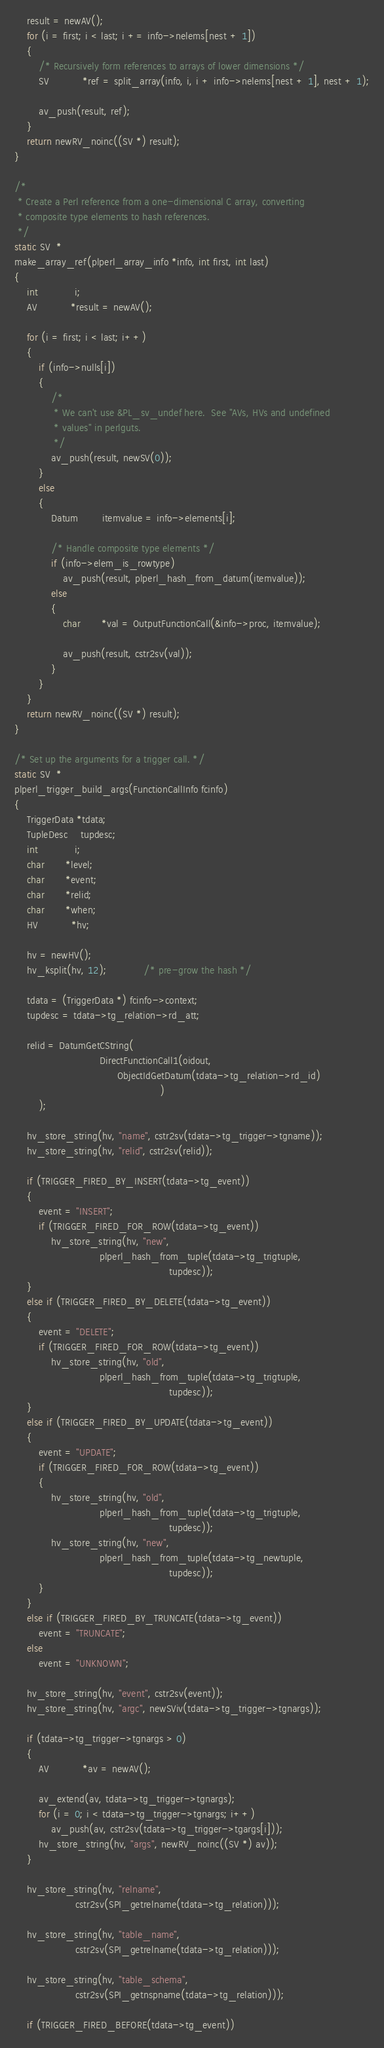<code> <loc_0><loc_0><loc_500><loc_500><_C_>	result = newAV();
	for (i = first; i < last; i += info->nelems[nest + 1])
	{
		/* Recursively form references to arrays of lower dimensions */
		SV		   *ref = split_array(info, i, i + info->nelems[nest + 1], nest + 1);

		av_push(result, ref);
	}
	return newRV_noinc((SV *) result);
}

/*
 * Create a Perl reference from a one-dimensional C array, converting
 * composite type elements to hash references.
 */
static SV  *
make_array_ref(plperl_array_info *info, int first, int last)
{
	int			i;
	AV		   *result = newAV();

	for (i = first; i < last; i++)
	{
		if (info->nulls[i])
		{
			/*
			 * We can't use &PL_sv_undef here.  See "AVs, HVs and undefined
			 * values" in perlguts.
			 */
			av_push(result, newSV(0));
		}
		else
		{
			Datum		itemvalue = info->elements[i];

			/* Handle composite type elements */
			if (info->elem_is_rowtype)
				av_push(result, plperl_hash_from_datum(itemvalue));
			else
			{
				char	   *val = OutputFunctionCall(&info->proc, itemvalue);

				av_push(result, cstr2sv(val));
			}
		}
	}
	return newRV_noinc((SV *) result);
}

/* Set up the arguments for a trigger call. */
static SV  *
plperl_trigger_build_args(FunctionCallInfo fcinfo)
{
	TriggerData *tdata;
	TupleDesc	tupdesc;
	int			i;
	char	   *level;
	char	   *event;
	char	   *relid;
	char	   *when;
	HV		   *hv;

	hv = newHV();
	hv_ksplit(hv, 12);			/* pre-grow the hash */

	tdata = (TriggerData *) fcinfo->context;
	tupdesc = tdata->tg_relation->rd_att;

	relid = DatumGetCString(
							DirectFunctionCall1(oidout,
								  ObjectIdGetDatum(tdata->tg_relation->rd_id)
												)
		);

	hv_store_string(hv, "name", cstr2sv(tdata->tg_trigger->tgname));
	hv_store_string(hv, "relid", cstr2sv(relid));

	if (TRIGGER_FIRED_BY_INSERT(tdata->tg_event))
	{
		event = "INSERT";
		if (TRIGGER_FIRED_FOR_ROW(tdata->tg_event))
			hv_store_string(hv, "new",
							plperl_hash_from_tuple(tdata->tg_trigtuple,
												   tupdesc));
	}
	else if (TRIGGER_FIRED_BY_DELETE(tdata->tg_event))
	{
		event = "DELETE";
		if (TRIGGER_FIRED_FOR_ROW(tdata->tg_event))
			hv_store_string(hv, "old",
							plperl_hash_from_tuple(tdata->tg_trigtuple,
												   tupdesc));
	}
	else if (TRIGGER_FIRED_BY_UPDATE(tdata->tg_event))
	{
		event = "UPDATE";
		if (TRIGGER_FIRED_FOR_ROW(tdata->tg_event))
		{
			hv_store_string(hv, "old",
							plperl_hash_from_tuple(tdata->tg_trigtuple,
												   tupdesc));
			hv_store_string(hv, "new",
							plperl_hash_from_tuple(tdata->tg_newtuple,
												   tupdesc));
		}
	}
	else if (TRIGGER_FIRED_BY_TRUNCATE(tdata->tg_event))
		event = "TRUNCATE";
	else
		event = "UNKNOWN";

	hv_store_string(hv, "event", cstr2sv(event));
	hv_store_string(hv, "argc", newSViv(tdata->tg_trigger->tgnargs));

	if (tdata->tg_trigger->tgnargs > 0)
	{
		AV		   *av = newAV();

		av_extend(av, tdata->tg_trigger->tgnargs);
		for (i = 0; i < tdata->tg_trigger->tgnargs; i++)
			av_push(av, cstr2sv(tdata->tg_trigger->tgargs[i]));
		hv_store_string(hv, "args", newRV_noinc((SV *) av));
	}

	hv_store_string(hv, "relname",
					cstr2sv(SPI_getrelname(tdata->tg_relation)));

	hv_store_string(hv, "table_name",
					cstr2sv(SPI_getrelname(tdata->tg_relation)));

	hv_store_string(hv, "table_schema",
					cstr2sv(SPI_getnspname(tdata->tg_relation)));

	if (TRIGGER_FIRED_BEFORE(tdata->tg_event))</code> 